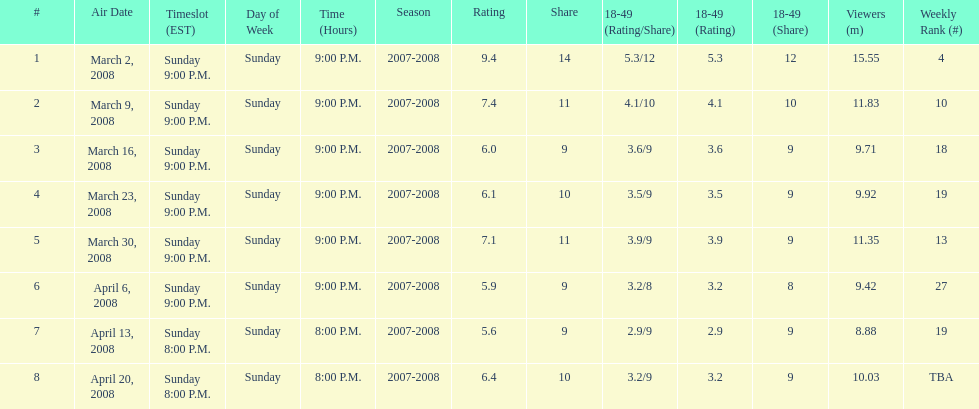How long did the program air for in days? 8. 